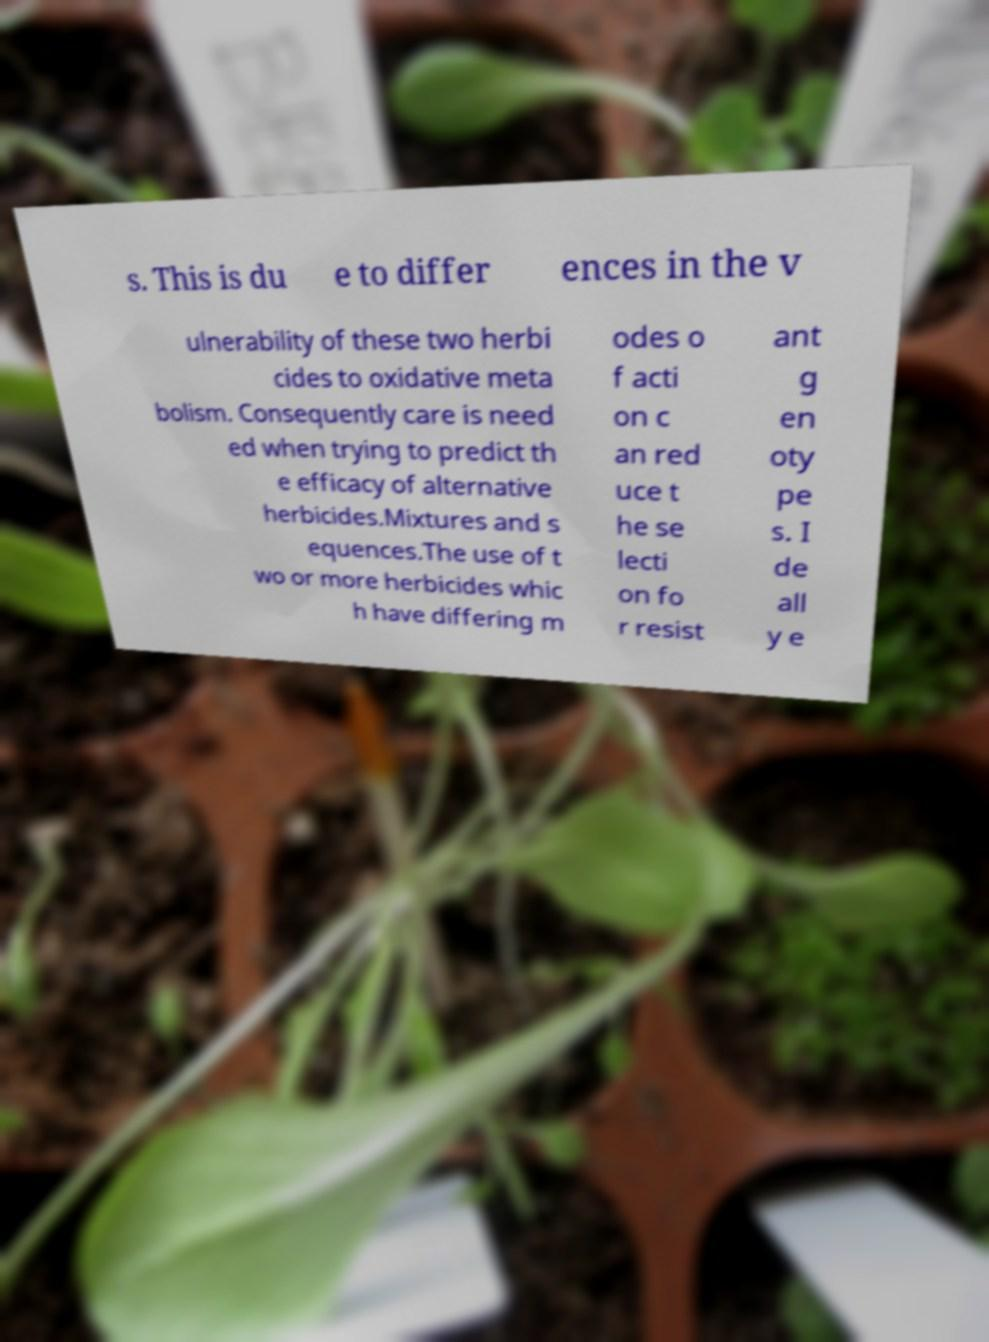What messages or text are displayed in this image? I need them in a readable, typed format. s. This is du e to differ ences in the v ulnerability of these two herbi cides to oxidative meta bolism. Consequently care is need ed when trying to predict th e efficacy of alternative herbicides.Mixtures and s equences.The use of t wo or more herbicides whic h have differing m odes o f acti on c an red uce t he se lecti on fo r resist ant g en oty pe s. I de all y e 